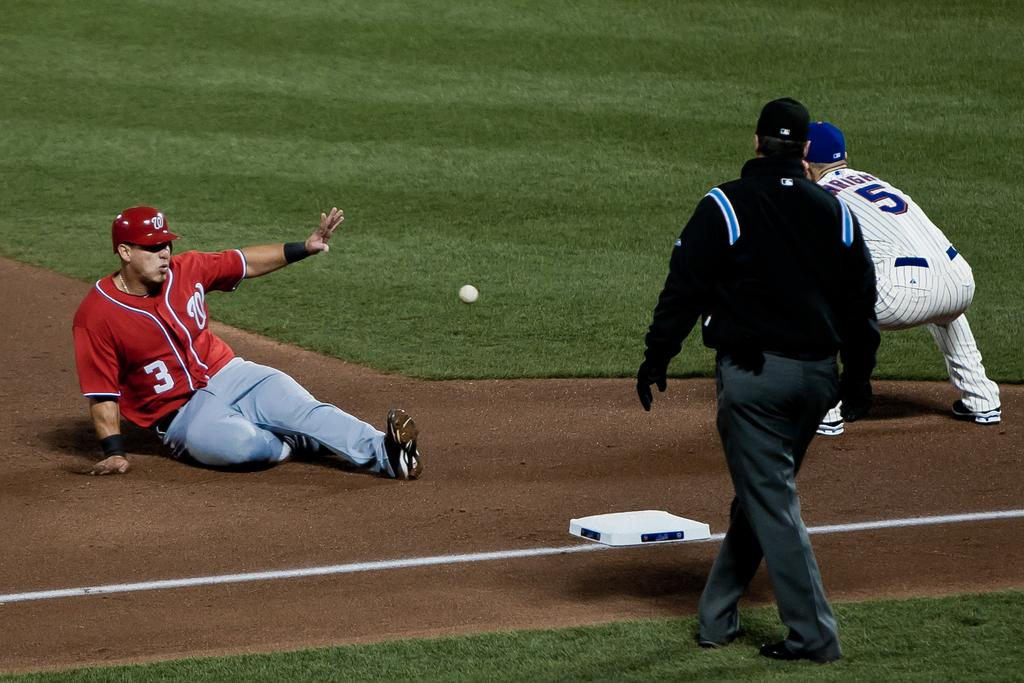<image>
Summarize the visual content of the image. a baseball game in progress, the ball is coming towards player 5 and runner with W and 3 on him is sliding on to the base. 